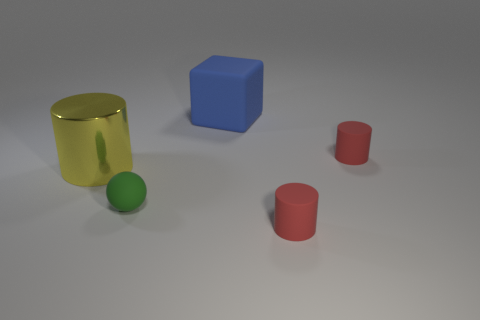Add 5 green matte things. How many objects exist? 10 Subtract all cubes. How many objects are left? 4 Subtract 0 cyan balls. How many objects are left? 5 Subtract all big blue matte cubes. Subtract all purple balls. How many objects are left? 4 Add 3 blue rubber cubes. How many blue rubber cubes are left? 4 Add 2 small green spheres. How many small green spheres exist? 3 